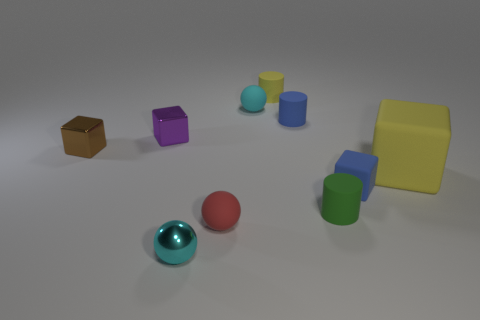Does the cyan rubber thing have the same size as the green object?
Keep it short and to the point. Yes. There is a thing that is the same color as the small shiny ball; what is its shape?
Your answer should be very brief. Sphere. How many things are either small matte cylinders that are in front of the small blue rubber block or brown shiny things?
Provide a succinct answer. 2. Are there any other shiny things of the same shape as the small purple thing?
Make the answer very short. Yes. What shape is the red thing that is the same size as the purple object?
Provide a short and direct response. Sphere. There is a tiny thing in front of the tiny matte ball that is in front of the rubber ball behind the red ball; what shape is it?
Provide a succinct answer. Sphere. Do the small green thing and the shiny object in front of the small blue matte block have the same shape?
Make the answer very short. No. What number of small things are yellow objects or cyan balls?
Offer a terse response. 3. Is there another shiny thing that has the same size as the red object?
Offer a terse response. Yes. What color is the small cube on the right side of the cyan ball that is to the right of the tiny metallic sphere that is in front of the yellow block?
Provide a succinct answer. Blue. 